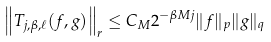<formula> <loc_0><loc_0><loc_500><loc_500>\left \| T _ { j , \beta , \ell } ( f , g ) \right \| _ { r } \leq C _ { M } 2 ^ { - \beta M j } \| f \| _ { p } \| g \| _ { q }</formula> 